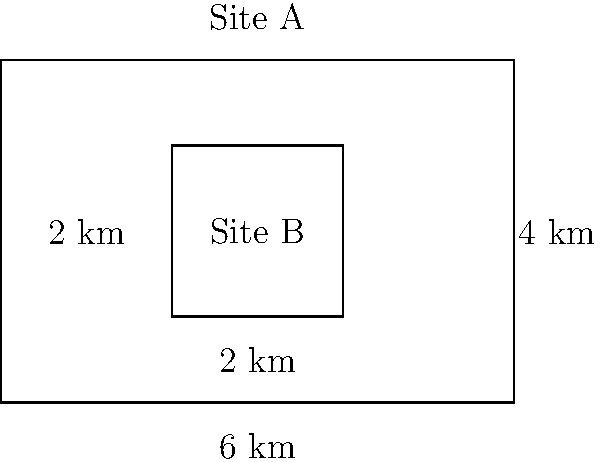As an IT manager evaluating potential data center locations, you are presented with two polygonal sites. Site A is a rectangle measuring 6 km by 4 km, while Site B is a smaller rectangle inside Site A, measuring 2 km by 2 km. What is the difference in area between Site A and Site B in square kilometers? To solve this problem, we need to follow these steps:

1. Calculate the area of Site A:
   Area of Site A = length × width
   $A_A = 6 \text{ km} \times 4 \text{ km} = 24 \text{ km}^2$

2. Calculate the area of Site B:
   Area of Site B = length × width
   $A_B = 2 \text{ km} \times 2 \text{ km} = 4 \text{ km}^2$

3. Calculate the difference in area:
   Difference = Area of Site A - Area of Site B
   $A_{diff} = A_A - A_B = 24 \text{ km}^2 - 4 \text{ km}^2 = 20 \text{ km}^2$

Therefore, the difference in area between Site A and Site B is 20 square kilometers.
Answer: $20 \text{ km}^2$ 